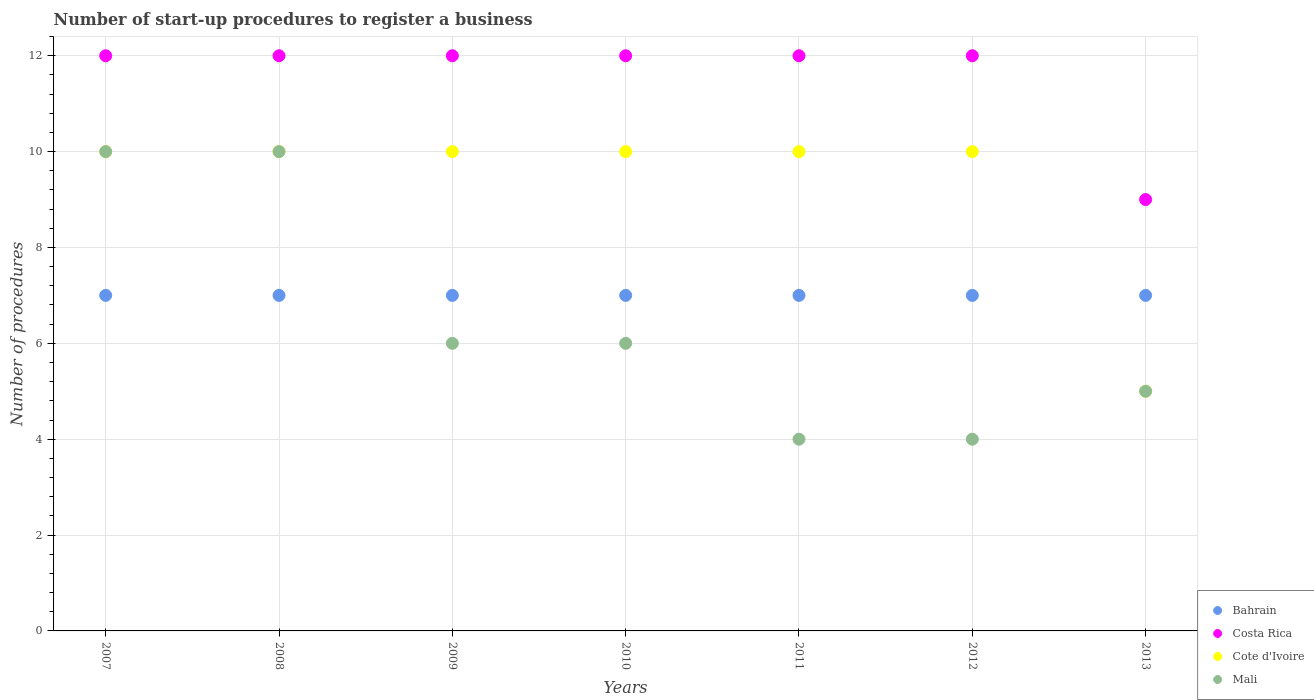How many different coloured dotlines are there?
Keep it short and to the point. 4. Is the number of dotlines equal to the number of legend labels?
Keep it short and to the point. Yes. What is the number of procedures required to register a business in Costa Rica in 2013?
Offer a terse response. 9. Across all years, what is the maximum number of procedures required to register a business in Mali?
Provide a succinct answer. 10. Across all years, what is the minimum number of procedures required to register a business in Costa Rica?
Provide a succinct answer. 9. In which year was the number of procedures required to register a business in Costa Rica minimum?
Make the answer very short. 2013. What is the difference between the number of procedures required to register a business in Bahrain in 2009 and that in 2011?
Provide a succinct answer. 0. What is the average number of procedures required to register a business in Mali per year?
Your answer should be compact. 6.43. What is the ratio of the number of procedures required to register a business in Mali in 2008 to that in 2010?
Your answer should be compact. 1.67. Is the number of procedures required to register a business in Costa Rica in 2011 less than that in 2012?
Provide a succinct answer. No. Is the difference between the number of procedures required to register a business in Mali in 2009 and 2013 greater than the difference between the number of procedures required to register a business in Cote d'Ivoire in 2009 and 2013?
Give a very brief answer. No. What is the difference between the highest and the lowest number of procedures required to register a business in Bahrain?
Your response must be concise. 0. Is it the case that in every year, the sum of the number of procedures required to register a business in Bahrain and number of procedures required to register a business in Costa Rica  is greater than the number of procedures required to register a business in Cote d'Ivoire?
Keep it short and to the point. Yes. Does the number of procedures required to register a business in Bahrain monotonically increase over the years?
Make the answer very short. No. Is the number of procedures required to register a business in Bahrain strictly greater than the number of procedures required to register a business in Mali over the years?
Make the answer very short. No. Is the number of procedures required to register a business in Mali strictly less than the number of procedures required to register a business in Cote d'Ivoire over the years?
Your answer should be compact. No. Does the graph contain any zero values?
Offer a very short reply. No. Where does the legend appear in the graph?
Ensure brevity in your answer.  Bottom right. How are the legend labels stacked?
Give a very brief answer. Vertical. What is the title of the graph?
Offer a terse response. Number of start-up procedures to register a business. Does "Trinidad and Tobago" appear as one of the legend labels in the graph?
Your response must be concise. No. What is the label or title of the X-axis?
Your answer should be very brief. Years. What is the label or title of the Y-axis?
Give a very brief answer. Number of procedures. What is the Number of procedures in Costa Rica in 2007?
Provide a short and direct response. 12. What is the Number of procedures in Cote d'Ivoire in 2007?
Give a very brief answer. 10. What is the Number of procedures of Costa Rica in 2008?
Ensure brevity in your answer.  12. What is the Number of procedures of Mali in 2008?
Your answer should be compact. 10. What is the Number of procedures of Bahrain in 2009?
Ensure brevity in your answer.  7. What is the Number of procedures in Cote d'Ivoire in 2009?
Your answer should be very brief. 10. What is the Number of procedures of Bahrain in 2010?
Your answer should be very brief. 7. What is the Number of procedures of Costa Rica in 2010?
Give a very brief answer. 12. What is the Number of procedures in Cote d'Ivoire in 2010?
Your response must be concise. 10. What is the Number of procedures of Mali in 2010?
Your response must be concise. 6. What is the Number of procedures of Bahrain in 2012?
Offer a very short reply. 7. What is the Number of procedures of Cote d'Ivoire in 2012?
Offer a terse response. 10. What is the Number of procedures of Bahrain in 2013?
Offer a very short reply. 7. What is the Number of procedures in Costa Rica in 2013?
Your response must be concise. 9. What is the Number of procedures in Cote d'Ivoire in 2013?
Ensure brevity in your answer.  5. Across all years, what is the maximum Number of procedures in Bahrain?
Make the answer very short. 7. Across all years, what is the maximum Number of procedures of Costa Rica?
Your answer should be compact. 12. Across all years, what is the minimum Number of procedures of Mali?
Make the answer very short. 4. What is the total Number of procedures in Bahrain in the graph?
Your response must be concise. 49. What is the total Number of procedures of Costa Rica in the graph?
Give a very brief answer. 81. What is the total Number of procedures of Mali in the graph?
Offer a terse response. 45. What is the difference between the Number of procedures in Cote d'Ivoire in 2007 and that in 2008?
Keep it short and to the point. 0. What is the difference between the Number of procedures in Mali in 2007 and that in 2008?
Ensure brevity in your answer.  0. What is the difference between the Number of procedures in Cote d'Ivoire in 2007 and that in 2009?
Make the answer very short. 0. What is the difference between the Number of procedures of Mali in 2007 and that in 2009?
Offer a very short reply. 4. What is the difference between the Number of procedures of Bahrain in 2007 and that in 2010?
Ensure brevity in your answer.  0. What is the difference between the Number of procedures of Mali in 2007 and that in 2010?
Give a very brief answer. 4. What is the difference between the Number of procedures of Costa Rica in 2007 and that in 2011?
Provide a short and direct response. 0. What is the difference between the Number of procedures in Cote d'Ivoire in 2007 and that in 2011?
Ensure brevity in your answer.  0. What is the difference between the Number of procedures in Bahrain in 2007 and that in 2012?
Offer a very short reply. 0. What is the difference between the Number of procedures of Costa Rica in 2007 and that in 2012?
Offer a very short reply. 0. What is the difference between the Number of procedures of Cote d'Ivoire in 2007 and that in 2012?
Your answer should be compact. 0. What is the difference between the Number of procedures of Cote d'Ivoire in 2007 and that in 2013?
Provide a succinct answer. 5. What is the difference between the Number of procedures of Bahrain in 2008 and that in 2009?
Make the answer very short. 0. What is the difference between the Number of procedures in Costa Rica in 2008 and that in 2009?
Your response must be concise. 0. What is the difference between the Number of procedures of Cote d'Ivoire in 2008 and that in 2009?
Provide a succinct answer. 0. What is the difference between the Number of procedures in Cote d'Ivoire in 2008 and that in 2010?
Offer a very short reply. 0. What is the difference between the Number of procedures in Costa Rica in 2008 and that in 2011?
Offer a terse response. 0. What is the difference between the Number of procedures of Mali in 2008 and that in 2011?
Offer a terse response. 6. What is the difference between the Number of procedures in Bahrain in 2008 and that in 2012?
Keep it short and to the point. 0. What is the difference between the Number of procedures in Cote d'Ivoire in 2008 and that in 2012?
Keep it short and to the point. 0. What is the difference between the Number of procedures in Mali in 2008 and that in 2012?
Your answer should be compact. 6. What is the difference between the Number of procedures in Bahrain in 2008 and that in 2013?
Offer a terse response. 0. What is the difference between the Number of procedures of Cote d'Ivoire in 2008 and that in 2013?
Keep it short and to the point. 5. What is the difference between the Number of procedures of Cote d'Ivoire in 2009 and that in 2010?
Your answer should be very brief. 0. What is the difference between the Number of procedures of Mali in 2009 and that in 2011?
Your answer should be compact. 2. What is the difference between the Number of procedures of Costa Rica in 2009 and that in 2012?
Give a very brief answer. 0. What is the difference between the Number of procedures of Bahrain in 2009 and that in 2013?
Provide a succinct answer. 0. What is the difference between the Number of procedures in Costa Rica in 2009 and that in 2013?
Ensure brevity in your answer.  3. What is the difference between the Number of procedures in Cote d'Ivoire in 2009 and that in 2013?
Provide a succinct answer. 5. What is the difference between the Number of procedures of Mali in 2010 and that in 2011?
Give a very brief answer. 2. What is the difference between the Number of procedures in Bahrain in 2010 and that in 2012?
Your answer should be very brief. 0. What is the difference between the Number of procedures in Cote d'Ivoire in 2010 and that in 2012?
Make the answer very short. 0. What is the difference between the Number of procedures of Mali in 2010 and that in 2012?
Your answer should be very brief. 2. What is the difference between the Number of procedures in Bahrain in 2010 and that in 2013?
Give a very brief answer. 0. What is the difference between the Number of procedures in Costa Rica in 2010 and that in 2013?
Provide a succinct answer. 3. What is the difference between the Number of procedures in Cote d'Ivoire in 2010 and that in 2013?
Offer a very short reply. 5. What is the difference between the Number of procedures in Mali in 2010 and that in 2013?
Keep it short and to the point. 1. What is the difference between the Number of procedures of Cote d'Ivoire in 2011 and that in 2012?
Keep it short and to the point. 0. What is the difference between the Number of procedures of Mali in 2011 and that in 2012?
Provide a short and direct response. 0. What is the difference between the Number of procedures in Cote d'Ivoire in 2011 and that in 2013?
Keep it short and to the point. 5. What is the difference between the Number of procedures of Mali in 2011 and that in 2013?
Offer a very short reply. -1. What is the difference between the Number of procedures of Bahrain in 2012 and that in 2013?
Provide a short and direct response. 0. What is the difference between the Number of procedures of Costa Rica in 2012 and that in 2013?
Offer a very short reply. 3. What is the difference between the Number of procedures in Cote d'Ivoire in 2012 and that in 2013?
Your answer should be very brief. 5. What is the difference between the Number of procedures of Bahrain in 2007 and the Number of procedures of Costa Rica in 2008?
Keep it short and to the point. -5. What is the difference between the Number of procedures of Bahrain in 2007 and the Number of procedures of Cote d'Ivoire in 2008?
Make the answer very short. -3. What is the difference between the Number of procedures of Costa Rica in 2007 and the Number of procedures of Cote d'Ivoire in 2008?
Ensure brevity in your answer.  2. What is the difference between the Number of procedures of Costa Rica in 2007 and the Number of procedures of Mali in 2008?
Your answer should be very brief. 2. What is the difference between the Number of procedures of Bahrain in 2007 and the Number of procedures of Cote d'Ivoire in 2009?
Make the answer very short. -3. What is the difference between the Number of procedures of Bahrain in 2007 and the Number of procedures of Mali in 2009?
Make the answer very short. 1. What is the difference between the Number of procedures of Costa Rica in 2007 and the Number of procedures of Mali in 2009?
Offer a terse response. 6. What is the difference between the Number of procedures in Bahrain in 2007 and the Number of procedures in Costa Rica in 2010?
Make the answer very short. -5. What is the difference between the Number of procedures of Costa Rica in 2007 and the Number of procedures of Cote d'Ivoire in 2010?
Offer a very short reply. 2. What is the difference between the Number of procedures in Cote d'Ivoire in 2007 and the Number of procedures in Mali in 2010?
Keep it short and to the point. 4. What is the difference between the Number of procedures of Bahrain in 2007 and the Number of procedures of Costa Rica in 2011?
Keep it short and to the point. -5. What is the difference between the Number of procedures in Bahrain in 2007 and the Number of procedures in Cote d'Ivoire in 2011?
Ensure brevity in your answer.  -3. What is the difference between the Number of procedures in Bahrain in 2007 and the Number of procedures in Mali in 2011?
Offer a terse response. 3. What is the difference between the Number of procedures of Bahrain in 2007 and the Number of procedures of Costa Rica in 2012?
Provide a short and direct response. -5. What is the difference between the Number of procedures of Bahrain in 2007 and the Number of procedures of Mali in 2012?
Ensure brevity in your answer.  3. What is the difference between the Number of procedures of Costa Rica in 2007 and the Number of procedures of Cote d'Ivoire in 2012?
Your response must be concise. 2. What is the difference between the Number of procedures in Bahrain in 2007 and the Number of procedures in Costa Rica in 2013?
Provide a succinct answer. -2. What is the difference between the Number of procedures in Bahrain in 2007 and the Number of procedures in Mali in 2013?
Provide a succinct answer. 2. What is the difference between the Number of procedures in Bahrain in 2008 and the Number of procedures in Costa Rica in 2009?
Offer a terse response. -5. What is the difference between the Number of procedures in Bahrain in 2008 and the Number of procedures in Mali in 2009?
Ensure brevity in your answer.  1. What is the difference between the Number of procedures in Costa Rica in 2008 and the Number of procedures in Cote d'Ivoire in 2009?
Offer a terse response. 2. What is the difference between the Number of procedures in Bahrain in 2008 and the Number of procedures in Mali in 2010?
Your answer should be very brief. 1. What is the difference between the Number of procedures of Costa Rica in 2008 and the Number of procedures of Cote d'Ivoire in 2010?
Keep it short and to the point. 2. What is the difference between the Number of procedures in Costa Rica in 2008 and the Number of procedures in Mali in 2010?
Your answer should be very brief. 6. What is the difference between the Number of procedures in Costa Rica in 2008 and the Number of procedures in Mali in 2011?
Provide a succinct answer. 8. What is the difference between the Number of procedures of Cote d'Ivoire in 2008 and the Number of procedures of Mali in 2011?
Make the answer very short. 6. What is the difference between the Number of procedures in Bahrain in 2008 and the Number of procedures in Cote d'Ivoire in 2012?
Give a very brief answer. -3. What is the difference between the Number of procedures of Costa Rica in 2008 and the Number of procedures of Cote d'Ivoire in 2012?
Keep it short and to the point. 2. What is the difference between the Number of procedures of Costa Rica in 2008 and the Number of procedures of Mali in 2012?
Offer a very short reply. 8. What is the difference between the Number of procedures of Cote d'Ivoire in 2008 and the Number of procedures of Mali in 2012?
Your answer should be very brief. 6. What is the difference between the Number of procedures in Bahrain in 2008 and the Number of procedures in Costa Rica in 2013?
Your answer should be very brief. -2. What is the difference between the Number of procedures of Bahrain in 2008 and the Number of procedures of Cote d'Ivoire in 2013?
Keep it short and to the point. 2. What is the difference between the Number of procedures in Bahrain in 2008 and the Number of procedures in Mali in 2013?
Offer a terse response. 2. What is the difference between the Number of procedures in Costa Rica in 2008 and the Number of procedures in Cote d'Ivoire in 2013?
Offer a terse response. 7. What is the difference between the Number of procedures of Costa Rica in 2008 and the Number of procedures of Mali in 2013?
Provide a short and direct response. 7. What is the difference between the Number of procedures of Costa Rica in 2009 and the Number of procedures of Cote d'Ivoire in 2010?
Provide a short and direct response. 2. What is the difference between the Number of procedures in Cote d'Ivoire in 2009 and the Number of procedures in Mali in 2010?
Offer a very short reply. 4. What is the difference between the Number of procedures in Bahrain in 2009 and the Number of procedures in Costa Rica in 2011?
Ensure brevity in your answer.  -5. What is the difference between the Number of procedures of Bahrain in 2009 and the Number of procedures of Mali in 2011?
Provide a short and direct response. 3. What is the difference between the Number of procedures in Costa Rica in 2009 and the Number of procedures in Cote d'Ivoire in 2011?
Offer a very short reply. 2. What is the difference between the Number of procedures in Cote d'Ivoire in 2009 and the Number of procedures in Mali in 2011?
Give a very brief answer. 6. What is the difference between the Number of procedures in Bahrain in 2009 and the Number of procedures in Costa Rica in 2012?
Provide a short and direct response. -5. What is the difference between the Number of procedures of Bahrain in 2009 and the Number of procedures of Mali in 2012?
Offer a terse response. 3. What is the difference between the Number of procedures of Costa Rica in 2009 and the Number of procedures of Cote d'Ivoire in 2012?
Provide a short and direct response. 2. What is the difference between the Number of procedures in Costa Rica in 2009 and the Number of procedures in Mali in 2012?
Ensure brevity in your answer.  8. What is the difference between the Number of procedures in Bahrain in 2009 and the Number of procedures in Cote d'Ivoire in 2013?
Your answer should be compact. 2. What is the difference between the Number of procedures of Bahrain in 2009 and the Number of procedures of Mali in 2013?
Keep it short and to the point. 2. What is the difference between the Number of procedures of Costa Rica in 2009 and the Number of procedures of Cote d'Ivoire in 2013?
Keep it short and to the point. 7. What is the difference between the Number of procedures of Costa Rica in 2009 and the Number of procedures of Mali in 2013?
Your response must be concise. 7. What is the difference between the Number of procedures in Bahrain in 2010 and the Number of procedures in Cote d'Ivoire in 2011?
Provide a short and direct response. -3. What is the difference between the Number of procedures in Costa Rica in 2010 and the Number of procedures in Cote d'Ivoire in 2011?
Provide a short and direct response. 2. What is the difference between the Number of procedures in Costa Rica in 2010 and the Number of procedures in Mali in 2011?
Your answer should be compact. 8. What is the difference between the Number of procedures of Bahrain in 2010 and the Number of procedures of Costa Rica in 2012?
Offer a very short reply. -5. What is the difference between the Number of procedures in Bahrain in 2010 and the Number of procedures in Cote d'Ivoire in 2012?
Provide a succinct answer. -3. What is the difference between the Number of procedures in Bahrain in 2010 and the Number of procedures in Mali in 2012?
Your answer should be very brief. 3. What is the difference between the Number of procedures in Costa Rica in 2010 and the Number of procedures in Cote d'Ivoire in 2012?
Offer a very short reply. 2. What is the difference between the Number of procedures of Bahrain in 2010 and the Number of procedures of Cote d'Ivoire in 2013?
Offer a very short reply. 2. What is the difference between the Number of procedures of Bahrain in 2010 and the Number of procedures of Mali in 2013?
Provide a succinct answer. 2. What is the difference between the Number of procedures of Costa Rica in 2010 and the Number of procedures of Cote d'Ivoire in 2013?
Your answer should be compact. 7. What is the difference between the Number of procedures in Costa Rica in 2010 and the Number of procedures in Mali in 2013?
Make the answer very short. 7. What is the difference between the Number of procedures of Cote d'Ivoire in 2010 and the Number of procedures of Mali in 2013?
Ensure brevity in your answer.  5. What is the difference between the Number of procedures in Bahrain in 2011 and the Number of procedures in Mali in 2012?
Give a very brief answer. 3. What is the difference between the Number of procedures of Costa Rica in 2011 and the Number of procedures of Cote d'Ivoire in 2012?
Provide a succinct answer. 2. What is the difference between the Number of procedures of Costa Rica in 2011 and the Number of procedures of Mali in 2012?
Offer a terse response. 8. What is the difference between the Number of procedures in Bahrain in 2011 and the Number of procedures in Costa Rica in 2013?
Give a very brief answer. -2. What is the difference between the Number of procedures in Bahrain in 2011 and the Number of procedures in Cote d'Ivoire in 2013?
Offer a very short reply. 2. What is the difference between the Number of procedures of Bahrain in 2011 and the Number of procedures of Mali in 2013?
Your answer should be very brief. 2. What is the difference between the Number of procedures of Costa Rica in 2011 and the Number of procedures of Mali in 2013?
Your response must be concise. 7. What is the difference between the Number of procedures of Bahrain in 2012 and the Number of procedures of Costa Rica in 2013?
Your response must be concise. -2. What is the difference between the Number of procedures in Bahrain in 2012 and the Number of procedures in Cote d'Ivoire in 2013?
Give a very brief answer. 2. What is the difference between the Number of procedures of Costa Rica in 2012 and the Number of procedures of Cote d'Ivoire in 2013?
Your answer should be very brief. 7. What is the difference between the Number of procedures of Costa Rica in 2012 and the Number of procedures of Mali in 2013?
Give a very brief answer. 7. What is the difference between the Number of procedures of Cote d'Ivoire in 2012 and the Number of procedures of Mali in 2013?
Provide a succinct answer. 5. What is the average Number of procedures of Bahrain per year?
Keep it short and to the point. 7. What is the average Number of procedures in Costa Rica per year?
Offer a terse response. 11.57. What is the average Number of procedures in Cote d'Ivoire per year?
Give a very brief answer. 9.29. What is the average Number of procedures in Mali per year?
Ensure brevity in your answer.  6.43. In the year 2007, what is the difference between the Number of procedures in Bahrain and Number of procedures in Cote d'Ivoire?
Make the answer very short. -3. In the year 2007, what is the difference between the Number of procedures in Costa Rica and Number of procedures in Mali?
Offer a terse response. 2. In the year 2008, what is the difference between the Number of procedures of Bahrain and Number of procedures of Costa Rica?
Your answer should be compact. -5. In the year 2008, what is the difference between the Number of procedures of Bahrain and Number of procedures of Cote d'Ivoire?
Your answer should be compact. -3. In the year 2008, what is the difference between the Number of procedures of Costa Rica and Number of procedures of Cote d'Ivoire?
Keep it short and to the point. 2. In the year 2008, what is the difference between the Number of procedures in Costa Rica and Number of procedures in Mali?
Keep it short and to the point. 2. In the year 2009, what is the difference between the Number of procedures in Cote d'Ivoire and Number of procedures in Mali?
Offer a very short reply. 4. In the year 2010, what is the difference between the Number of procedures in Bahrain and Number of procedures in Cote d'Ivoire?
Make the answer very short. -3. In the year 2010, what is the difference between the Number of procedures in Bahrain and Number of procedures in Mali?
Give a very brief answer. 1. In the year 2010, what is the difference between the Number of procedures of Costa Rica and Number of procedures of Mali?
Provide a succinct answer. 6. In the year 2010, what is the difference between the Number of procedures in Cote d'Ivoire and Number of procedures in Mali?
Keep it short and to the point. 4. In the year 2011, what is the difference between the Number of procedures in Bahrain and Number of procedures in Costa Rica?
Your answer should be compact. -5. In the year 2011, what is the difference between the Number of procedures in Bahrain and Number of procedures in Mali?
Your answer should be compact. 3. In the year 2012, what is the difference between the Number of procedures of Bahrain and Number of procedures of Costa Rica?
Offer a very short reply. -5. In the year 2012, what is the difference between the Number of procedures of Bahrain and Number of procedures of Mali?
Your response must be concise. 3. In the year 2012, what is the difference between the Number of procedures of Costa Rica and Number of procedures of Mali?
Give a very brief answer. 8. In the year 2013, what is the difference between the Number of procedures of Costa Rica and Number of procedures of Cote d'Ivoire?
Provide a succinct answer. 4. In the year 2013, what is the difference between the Number of procedures in Costa Rica and Number of procedures in Mali?
Keep it short and to the point. 4. In the year 2013, what is the difference between the Number of procedures in Cote d'Ivoire and Number of procedures in Mali?
Make the answer very short. 0. What is the ratio of the Number of procedures in Bahrain in 2007 to that in 2008?
Make the answer very short. 1. What is the ratio of the Number of procedures in Costa Rica in 2007 to that in 2008?
Provide a short and direct response. 1. What is the ratio of the Number of procedures of Cote d'Ivoire in 2007 to that in 2009?
Offer a terse response. 1. What is the ratio of the Number of procedures in Mali in 2007 to that in 2009?
Keep it short and to the point. 1.67. What is the ratio of the Number of procedures of Bahrain in 2007 to that in 2010?
Provide a succinct answer. 1. What is the ratio of the Number of procedures in Costa Rica in 2007 to that in 2010?
Offer a very short reply. 1. What is the ratio of the Number of procedures of Cote d'Ivoire in 2007 to that in 2010?
Keep it short and to the point. 1. What is the ratio of the Number of procedures in Costa Rica in 2007 to that in 2011?
Ensure brevity in your answer.  1. What is the ratio of the Number of procedures in Cote d'Ivoire in 2007 to that in 2011?
Provide a short and direct response. 1. What is the ratio of the Number of procedures in Mali in 2007 to that in 2011?
Your response must be concise. 2.5. What is the ratio of the Number of procedures in Bahrain in 2007 to that in 2012?
Offer a terse response. 1. What is the ratio of the Number of procedures in Bahrain in 2007 to that in 2013?
Your answer should be compact. 1. What is the ratio of the Number of procedures of Costa Rica in 2007 to that in 2013?
Your answer should be compact. 1.33. What is the ratio of the Number of procedures of Cote d'Ivoire in 2007 to that in 2013?
Ensure brevity in your answer.  2. What is the ratio of the Number of procedures in Mali in 2007 to that in 2013?
Offer a very short reply. 2. What is the ratio of the Number of procedures of Bahrain in 2008 to that in 2009?
Provide a succinct answer. 1. What is the ratio of the Number of procedures of Costa Rica in 2008 to that in 2009?
Offer a terse response. 1. What is the ratio of the Number of procedures in Mali in 2008 to that in 2009?
Make the answer very short. 1.67. What is the ratio of the Number of procedures of Costa Rica in 2008 to that in 2010?
Keep it short and to the point. 1. What is the ratio of the Number of procedures of Mali in 2008 to that in 2010?
Keep it short and to the point. 1.67. What is the ratio of the Number of procedures of Bahrain in 2008 to that in 2011?
Your answer should be very brief. 1. What is the ratio of the Number of procedures of Mali in 2008 to that in 2011?
Your response must be concise. 2.5. What is the ratio of the Number of procedures of Costa Rica in 2008 to that in 2012?
Keep it short and to the point. 1. What is the ratio of the Number of procedures in Costa Rica in 2008 to that in 2013?
Your response must be concise. 1.33. What is the ratio of the Number of procedures of Cote d'Ivoire in 2008 to that in 2013?
Your answer should be compact. 2. What is the ratio of the Number of procedures of Costa Rica in 2009 to that in 2010?
Make the answer very short. 1. What is the ratio of the Number of procedures in Mali in 2009 to that in 2010?
Keep it short and to the point. 1. What is the ratio of the Number of procedures in Bahrain in 2009 to that in 2011?
Your answer should be very brief. 1. What is the ratio of the Number of procedures in Cote d'Ivoire in 2009 to that in 2011?
Your answer should be compact. 1. What is the ratio of the Number of procedures of Bahrain in 2009 to that in 2012?
Make the answer very short. 1. What is the ratio of the Number of procedures in Cote d'Ivoire in 2009 to that in 2012?
Provide a short and direct response. 1. What is the ratio of the Number of procedures of Costa Rica in 2009 to that in 2013?
Your answer should be compact. 1.33. What is the ratio of the Number of procedures in Cote d'Ivoire in 2009 to that in 2013?
Ensure brevity in your answer.  2. What is the ratio of the Number of procedures of Mali in 2009 to that in 2013?
Provide a short and direct response. 1.2. What is the ratio of the Number of procedures in Costa Rica in 2010 to that in 2011?
Offer a terse response. 1. What is the ratio of the Number of procedures in Cote d'Ivoire in 2010 to that in 2011?
Offer a very short reply. 1. What is the ratio of the Number of procedures in Mali in 2010 to that in 2011?
Provide a succinct answer. 1.5. What is the ratio of the Number of procedures of Bahrain in 2010 to that in 2012?
Provide a succinct answer. 1. What is the ratio of the Number of procedures of Cote d'Ivoire in 2010 to that in 2012?
Your answer should be very brief. 1. What is the ratio of the Number of procedures in Mali in 2010 to that in 2012?
Offer a terse response. 1.5. What is the ratio of the Number of procedures in Costa Rica in 2010 to that in 2013?
Your response must be concise. 1.33. What is the ratio of the Number of procedures in Cote d'Ivoire in 2010 to that in 2013?
Offer a very short reply. 2. What is the ratio of the Number of procedures in Bahrain in 2011 to that in 2012?
Keep it short and to the point. 1. What is the ratio of the Number of procedures of Cote d'Ivoire in 2011 to that in 2012?
Offer a very short reply. 1. What is the ratio of the Number of procedures of Mali in 2011 to that in 2012?
Offer a terse response. 1. What is the ratio of the Number of procedures in Costa Rica in 2011 to that in 2013?
Your answer should be very brief. 1.33. What is the ratio of the Number of procedures of Cote d'Ivoire in 2011 to that in 2013?
Your response must be concise. 2. What is the ratio of the Number of procedures of Costa Rica in 2012 to that in 2013?
Provide a succinct answer. 1.33. What is the difference between the highest and the second highest Number of procedures in Bahrain?
Provide a short and direct response. 0. What is the difference between the highest and the second highest Number of procedures of Cote d'Ivoire?
Provide a short and direct response. 0. What is the difference between the highest and the second highest Number of procedures of Mali?
Provide a succinct answer. 0. What is the difference between the highest and the lowest Number of procedures of Cote d'Ivoire?
Make the answer very short. 5. What is the difference between the highest and the lowest Number of procedures in Mali?
Provide a succinct answer. 6. 